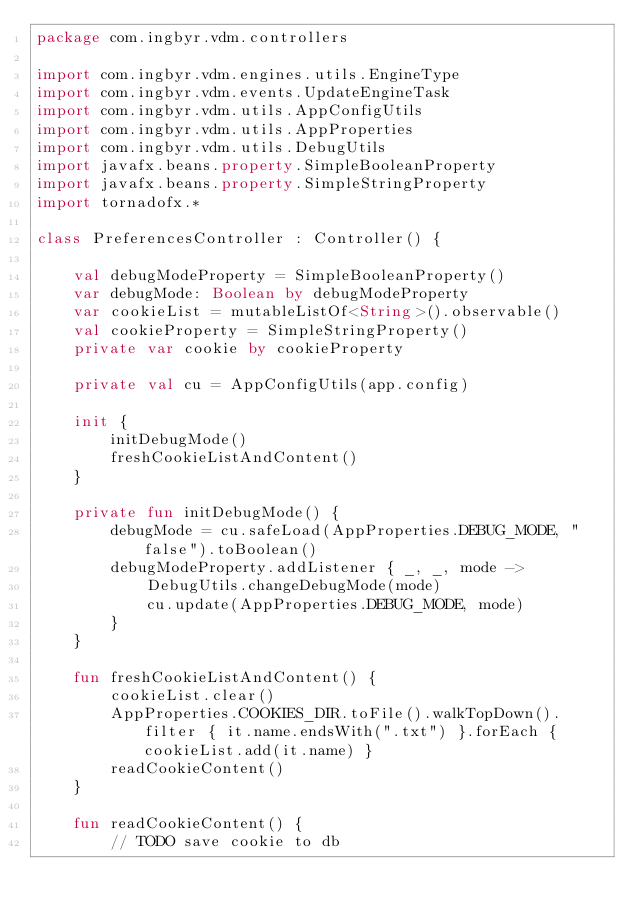<code> <loc_0><loc_0><loc_500><loc_500><_Kotlin_>package com.ingbyr.vdm.controllers

import com.ingbyr.vdm.engines.utils.EngineType
import com.ingbyr.vdm.events.UpdateEngineTask
import com.ingbyr.vdm.utils.AppConfigUtils
import com.ingbyr.vdm.utils.AppProperties
import com.ingbyr.vdm.utils.DebugUtils
import javafx.beans.property.SimpleBooleanProperty
import javafx.beans.property.SimpleStringProperty
import tornadofx.*

class PreferencesController : Controller() {

    val debugModeProperty = SimpleBooleanProperty()
    var debugMode: Boolean by debugModeProperty
    var cookieList = mutableListOf<String>().observable()
    val cookieProperty = SimpleStringProperty()
    private var cookie by cookieProperty

    private val cu = AppConfigUtils(app.config)

    init {
        initDebugMode()
        freshCookieListAndContent()
    }

    private fun initDebugMode() {
        debugMode = cu.safeLoad(AppProperties.DEBUG_MODE, "false").toBoolean()
        debugModeProperty.addListener { _, _, mode ->
            DebugUtils.changeDebugMode(mode)
            cu.update(AppProperties.DEBUG_MODE, mode)
        }
    }

    fun freshCookieListAndContent() {
        cookieList.clear()
        AppProperties.COOKIES_DIR.toFile().walkTopDown().filter { it.name.endsWith(".txt") }.forEach { cookieList.add(it.name) }
        readCookieContent()
    }

    fun readCookieContent() {
        // TODO save cookie to db</code> 